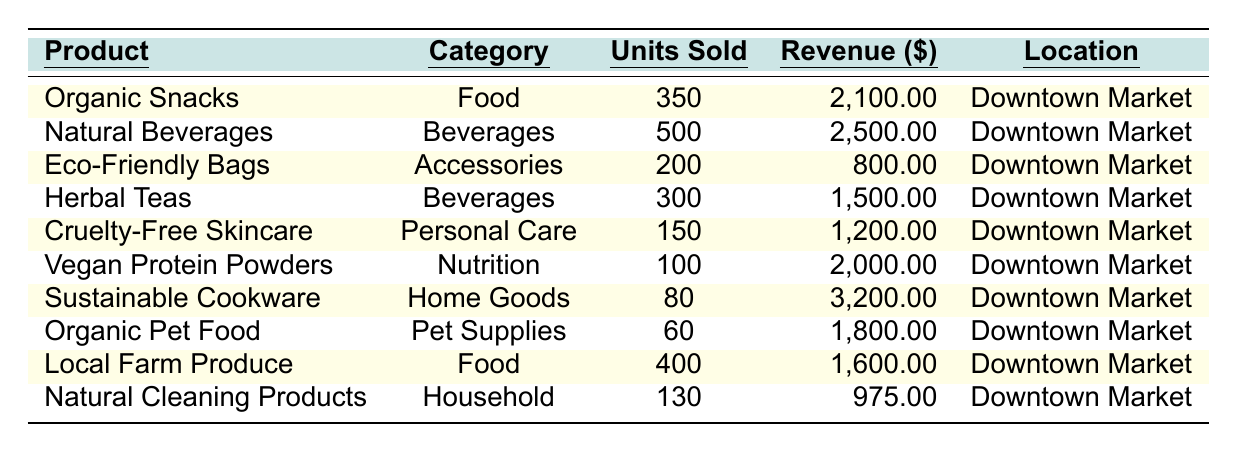What product had the highest total revenue in 2021? The product with the highest total revenue can be identified by reviewing the "Revenue ($)" column of the table. The values are: Organic Snacks ($2,100), Natural Beverages ($2,500), Eco-Friendly Bags ($800), Herbal Teas ($1,500), Cruelty-Free Skincare ($1,200), Vegan Protein Powders ($2,000), Sustainable Cookware ($3,200), Organic Pet Food ($1,800), Local Farm Produce ($1,600), and Natural Cleaning Products ($975). The highest value is $3,200 from Sustainable Cookware.
Answer: Sustainable Cookware How many units of Natural Beverages were sold? The table directly lists the units sold for each product. For Natural Beverages, the "Units Sold" column shows a value of 500.
Answer: 500 What is the total revenue generated from Food products? The Food products listed are Organic Snacks (revenue $2,100) and Local Farm Produce (revenue $1,600). To find the total revenue, we add these two values: $2,100 + $1,600 = $3,700.
Answer: $3,700 Is there a product from the Household category? By checking the "Category" column, we see Natural Cleaning Products listed under "Household." Therefore, there is indeed a product from this category.
Answer: Yes What is the average revenue of all products listed under the Beverages category? The Beverages category includes Natural Beverages ($2,500) and Herbal Teas ($1,500). First, we sum their revenues: $2,500 + $1,500 = $4,000. Next, we divide by the number of products in this category, which is 2. Thus, the average revenue is $4,000 / 2 = $2,000.
Answer: $2,000 Which location had the highest units sold for any product? To determine the location with the highest units sold, we look for the highest value in the "Units Sold" column. The highest value (500 units) corresponds to Natural Beverages, which is located in Downtown Market. Since all products are sold at the same location, Downtown Market has the highest units sold.
Answer: Downtown Market Calculate the difference in revenue between the product with the highest revenue and the product with the lowest revenue. From the table, the product with the highest revenue is Sustainable Cookware ($3,200), and the product with the lowest revenue is Eco-Friendly Bags ($800). To find the difference, we subtract the lowest from the highest: $3,200 - $800 = $2,400.
Answer: $2,400 How many more units were sold of Organic Snacks compared to Eco-Friendly Bags? The table indicates that Organic Snacks sold 350 units while Eco-Friendly Bags sold 200 units. The difference is calculated as 350 - 200 = 150.
Answer: 150 Determine the total units sold across all product categories. We sum the units sold for each product listed: 350 (Organic Snacks) + 500 (Natural Beverages) + 200 (Eco-Friendly Bags) + 300 (Herbal Teas) + 150 (Cruelty-Free Skincare) + 100 (Vegan Protein Powders) + 80 (Sustainable Cookware) + 60 (Organic Pet Food) + 400 (Local Farm Produce) + 130 (Natural Cleaning Products) = 1,970.
Answer: 1,970 